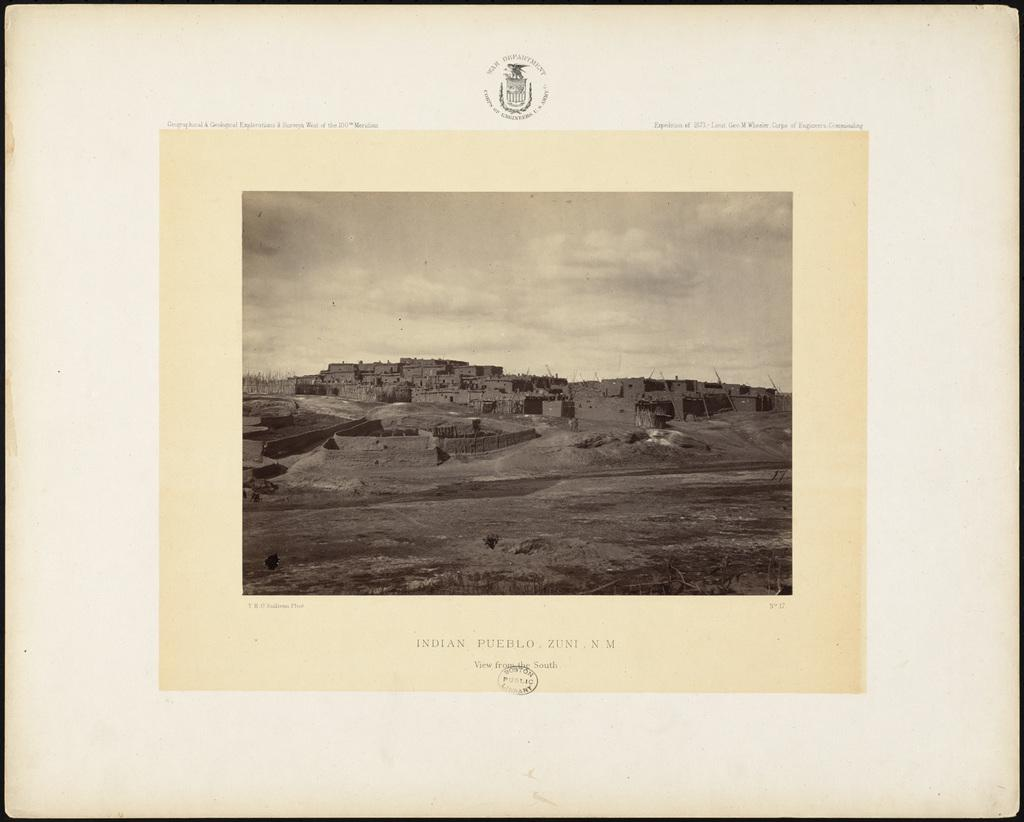<image>
Offer a succinct explanation of the picture presented. The word "Indian Pueblo" is used to describe the image above it. 